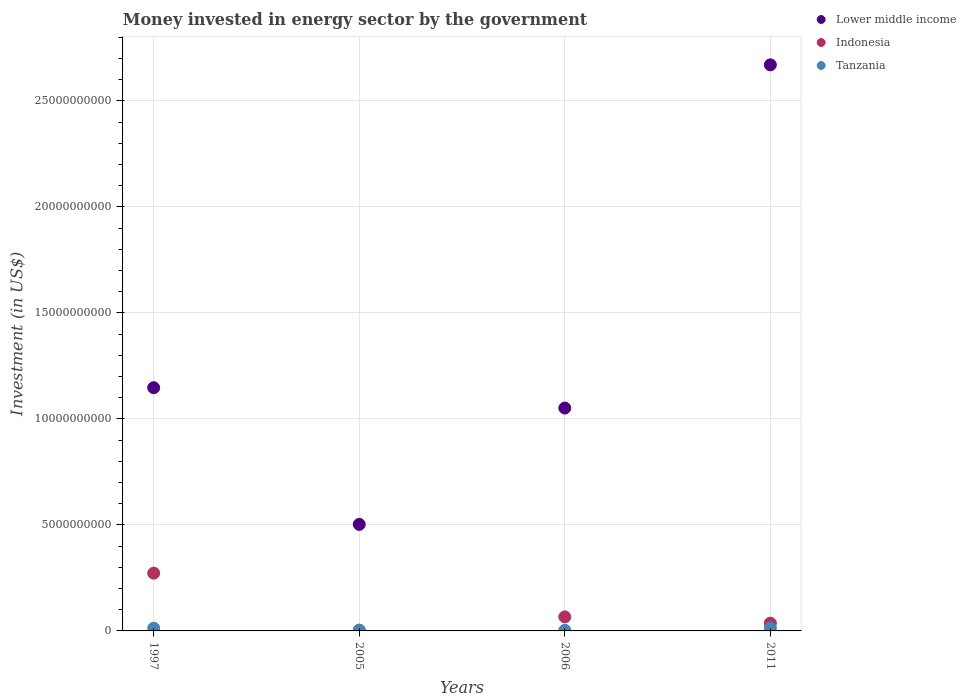How many different coloured dotlines are there?
Offer a very short reply. 3. Is the number of dotlines equal to the number of legend labels?
Ensure brevity in your answer.  Yes. What is the money spent in energy sector in Indonesia in 2006?
Ensure brevity in your answer.  6.62e+08. Across all years, what is the maximum money spent in energy sector in Tanzania?
Offer a terse response. 1.34e+08. Across all years, what is the minimum money spent in energy sector in Lower middle income?
Your answer should be very brief. 5.03e+09. What is the total money spent in energy sector in Tanzania in the graph?
Keep it short and to the point. 3.22e+08. What is the difference between the money spent in energy sector in Tanzania in 2006 and that in 2011?
Give a very brief answer. -1.06e+08. What is the difference between the money spent in energy sector in Lower middle income in 2006 and the money spent in energy sector in Indonesia in 1997?
Offer a terse response. 7.79e+09. What is the average money spent in energy sector in Tanzania per year?
Provide a short and direct response. 8.04e+07. In the year 2005, what is the difference between the money spent in energy sector in Lower middle income and money spent in energy sector in Tanzania?
Give a very brief answer. 4.99e+09. What is the ratio of the money spent in energy sector in Indonesia in 2006 to that in 2011?
Provide a short and direct response. 1.81. What is the difference between the highest and the second highest money spent in energy sector in Tanzania?
Ensure brevity in your answer.  7.10e+06. What is the difference between the highest and the lowest money spent in energy sector in Tanzania?
Your answer should be very brief. 1.06e+08. Does the money spent in energy sector in Indonesia monotonically increase over the years?
Make the answer very short. No. How many dotlines are there?
Your response must be concise. 3. How many years are there in the graph?
Ensure brevity in your answer.  4. Are the values on the major ticks of Y-axis written in scientific E-notation?
Give a very brief answer. No. Where does the legend appear in the graph?
Keep it short and to the point. Top right. What is the title of the graph?
Provide a succinct answer. Money invested in energy sector by the government. What is the label or title of the X-axis?
Your response must be concise. Years. What is the label or title of the Y-axis?
Offer a terse response. Investment (in US$). What is the Investment (in US$) in Lower middle income in 1997?
Offer a very short reply. 1.15e+1. What is the Investment (in US$) in Indonesia in 1997?
Provide a succinct answer. 2.72e+09. What is the Investment (in US$) in Tanzania in 1997?
Your response must be concise. 1.27e+08. What is the Investment (in US$) in Lower middle income in 2005?
Your answer should be compact. 5.03e+09. What is the Investment (in US$) of Indonesia in 2005?
Offer a terse response. 3.20e+07. What is the Investment (in US$) of Tanzania in 2005?
Make the answer very short. 3.20e+07. What is the Investment (in US$) in Lower middle income in 2006?
Make the answer very short. 1.05e+1. What is the Investment (in US$) in Indonesia in 2006?
Offer a very short reply. 6.62e+08. What is the Investment (in US$) of Tanzania in 2006?
Make the answer very short. 2.84e+07. What is the Investment (in US$) of Lower middle income in 2011?
Your response must be concise. 2.67e+1. What is the Investment (in US$) in Indonesia in 2011?
Your answer should be very brief. 3.66e+08. What is the Investment (in US$) of Tanzania in 2011?
Provide a short and direct response. 1.34e+08. Across all years, what is the maximum Investment (in US$) in Lower middle income?
Offer a very short reply. 2.67e+1. Across all years, what is the maximum Investment (in US$) in Indonesia?
Your answer should be compact. 2.72e+09. Across all years, what is the maximum Investment (in US$) of Tanzania?
Give a very brief answer. 1.34e+08. Across all years, what is the minimum Investment (in US$) in Lower middle income?
Ensure brevity in your answer.  5.03e+09. Across all years, what is the minimum Investment (in US$) of Indonesia?
Your answer should be very brief. 3.20e+07. Across all years, what is the minimum Investment (in US$) of Tanzania?
Ensure brevity in your answer.  2.84e+07. What is the total Investment (in US$) in Lower middle income in the graph?
Offer a terse response. 5.37e+1. What is the total Investment (in US$) of Indonesia in the graph?
Provide a succinct answer. 3.78e+09. What is the total Investment (in US$) of Tanzania in the graph?
Provide a short and direct response. 3.22e+08. What is the difference between the Investment (in US$) in Lower middle income in 1997 and that in 2005?
Make the answer very short. 6.45e+09. What is the difference between the Investment (in US$) in Indonesia in 1997 and that in 2005?
Your answer should be compact. 2.69e+09. What is the difference between the Investment (in US$) in Tanzania in 1997 and that in 2005?
Provide a short and direct response. 9.50e+07. What is the difference between the Investment (in US$) in Lower middle income in 1997 and that in 2006?
Offer a very short reply. 9.60e+08. What is the difference between the Investment (in US$) in Indonesia in 1997 and that in 2006?
Make the answer very short. 2.06e+09. What is the difference between the Investment (in US$) in Tanzania in 1997 and that in 2006?
Your response must be concise. 9.86e+07. What is the difference between the Investment (in US$) in Lower middle income in 1997 and that in 2011?
Give a very brief answer. -1.52e+1. What is the difference between the Investment (in US$) in Indonesia in 1997 and that in 2011?
Provide a succinct answer. 2.36e+09. What is the difference between the Investment (in US$) of Tanzania in 1997 and that in 2011?
Provide a short and direct response. -7.10e+06. What is the difference between the Investment (in US$) in Lower middle income in 2005 and that in 2006?
Your answer should be compact. -5.49e+09. What is the difference between the Investment (in US$) of Indonesia in 2005 and that in 2006?
Your answer should be compact. -6.30e+08. What is the difference between the Investment (in US$) in Tanzania in 2005 and that in 2006?
Offer a very short reply. 3.60e+06. What is the difference between the Investment (in US$) in Lower middle income in 2005 and that in 2011?
Your response must be concise. -2.17e+1. What is the difference between the Investment (in US$) of Indonesia in 2005 and that in 2011?
Keep it short and to the point. -3.34e+08. What is the difference between the Investment (in US$) in Tanzania in 2005 and that in 2011?
Your answer should be compact. -1.02e+08. What is the difference between the Investment (in US$) of Lower middle income in 2006 and that in 2011?
Provide a short and direct response. -1.62e+1. What is the difference between the Investment (in US$) in Indonesia in 2006 and that in 2011?
Offer a very short reply. 2.96e+08. What is the difference between the Investment (in US$) in Tanzania in 2006 and that in 2011?
Provide a succinct answer. -1.06e+08. What is the difference between the Investment (in US$) of Lower middle income in 1997 and the Investment (in US$) of Indonesia in 2005?
Provide a short and direct response. 1.14e+1. What is the difference between the Investment (in US$) in Lower middle income in 1997 and the Investment (in US$) in Tanzania in 2005?
Offer a terse response. 1.14e+1. What is the difference between the Investment (in US$) of Indonesia in 1997 and the Investment (in US$) of Tanzania in 2005?
Your answer should be compact. 2.69e+09. What is the difference between the Investment (in US$) of Lower middle income in 1997 and the Investment (in US$) of Indonesia in 2006?
Your response must be concise. 1.08e+1. What is the difference between the Investment (in US$) in Lower middle income in 1997 and the Investment (in US$) in Tanzania in 2006?
Your answer should be compact. 1.14e+1. What is the difference between the Investment (in US$) of Indonesia in 1997 and the Investment (in US$) of Tanzania in 2006?
Make the answer very short. 2.70e+09. What is the difference between the Investment (in US$) of Lower middle income in 1997 and the Investment (in US$) of Indonesia in 2011?
Your answer should be compact. 1.11e+1. What is the difference between the Investment (in US$) of Lower middle income in 1997 and the Investment (in US$) of Tanzania in 2011?
Ensure brevity in your answer.  1.13e+1. What is the difference between the Investment (in US$) in Indonesia in 1997 and the Investment (in US$) in Tanzania in 2011?
Keep it short and to the point. 2.59e+09. What is the difference between the Investment (in US$) of Lower middle income in 2005 and the Investment (in US$) of Indonesia in 2006?
Ensure brevity in your answer.  4.36e+09. What is the difference between the Investment (in US$) of Lower middle income in 2005 and the Investment (in US$) of Tanzania in 2006?
Offer a very short reply. 5.00e+09. What is the difference between the Investment (in US$) in Indonesia in 2005 and the Investment (in US$) in Tanzania in 2006?
Your answer should be compact. 3.60e+06. What is the difference between the Investment (in US$) of Lower middle income in 2005 and the Investment (in US$) of Indonesia in 2011?
Provide a succinct answer. 4.66e+09. What is the difference between the Investment (in US$) of Lower middle income in 2005 and the Investment (in US$) of Tanzania in 2011?
Your response must be concise. 4.89e+09. What is the difference between the Investment (in US$) in Indonesia in 2005 and the Investment (in US$) in Tanzania in 2011?
Provide a succinct answer. -1.02e+08. What is the difference between the Investment (in US$) in Lower middle income in 2006 and the Investment (in US$) in Indonesia in 2011?
Provide a succinct answer. 1.01e+1. What is the difference between the Investment (in US$) in Lower middle income in 2006 and the Investment (in US$) in Tanzania in 2011?
Make the answer very short. 1.04e+1. What is the difference between the Investment (in US$) of Indonesia in 2006 and the Investment (in US$) of Tanzania in 2011?
Offer a terse response. 5.28e+08. What is the average Investment (in US$) of Lower middle income per year?
Your answer should be very brief. 1.34e+1. What is the average Investment (in US$) in Indonesia per year?
Your answer should be compact. 9.46e+08. What is the average Investment (in US$) of Tanzania per year?
Ensure brevity in your answer.  8.04e+07. In the year 1997, what is the difference between the Investment (in US$) in Lower middle income and Investment (in US$) in Indonesia?
Your response must be concise. 8.75e+09. In the year 1997, what is the difference between the Investment (in US$) of Lower middle income and Investment (in US$) of Tanzania?
Make the answer very short. 1.13e+1. In the year 1997, what is the difference between the Investment (in US$) in Indonesia and Investment (in US$) in Tanzania?
Give a very brief answer. 2.60e+09. In the year 2005, what is the difference between the Investment (in US$) of Lower middle income and Investment (in US$) of Indonesia?
Offer a very short reply. 4.99e+09. In the year 2005, what is the difference between the Investment (in US$) in Lower middle income and Investment (in US$) in Tanzania?
Offer a terse response. 4.99e+09. In the year 2005, what is the difference between the Investment (in US$) in Indonesia and Investment (in US$) in Tanzania?
Offer a very short reply. 0. In the year 2006, what is the difference between the Investment (in US$) of Lower middle income and Investment (in US$) of Indonesia?
Offer a terse response. 9.85e+09. In the year 2006, what is the difference between the Investment (in US$) in Lower middle income and Investment (in US$) in Tanzania?
Offer a very short reply. 1.05e+1. In the year 2006, what is the difference between the Investment (in US$) of Indonesia and Investment (in US$) of Tanzania?
Your answer should be very brief. 6.34e+08. In the year 2011, what is the difference between the Investment (in US$) of Lower middle income and Investment (in US$) of Indonesia?
Your answer should be very brief. 2.63e+1. In the year 2011, what is the difference between the Investment (in US$) of Lower middle income and Investment (in US$) of Tanzania?
Ensure brevity in your answer.  2.66e+1. In the year 2011, what is the difference between the Investment (in US$) of Indonesia and Investment (in US$) of Tanzania?
Make the answer very short. 2.32e+08. What is the ratio of the Investment (in US$) of Lower middle income in 1997 to that in 2005?
Keep it short and to the point. 2.28. What is the ratio of the Investment (in US$) in Indonesia in 1997 to that in 2005?
Your answer should be very brief. 85.16. What is the ratio of the Investment (in US$) of Tanzania in 1997 to that in 2005?
Your answer should be compact. 3.97. What is the ratio of the Investment (in US$) in Lower middle income in 1997 to that in 2006?
Offer a very short reply. 1.09. What is the ratio of the Investment (in US$) of Indonesia in 1997 to that in 2006?
Your answer should be compact. 4.12. What is the ratio of the Investment (in US$) in Tanzania in 1997 to that in 2006?
Make the answer very short. 4.47. What is the ratio of the Investment (in US$) of Lower middle income in 1997 to that in 2011?
Keep it short and to the point. 0.43. What is the ratio of the Investment (in US$) in Indonesia in 1997 to that in 2011?
Ensure brevity in your answer.  7.45. What is the ratio of the Investment (in US$) of Tanzania in 1997 to that in 2011?
Your response must be concise. 0.95. What is the ratio of the Investment (in US$) of Lower middle income in 2005 to that in 2006?
Provide a short and direct response. 0.48. What is the ratio of the Investment (in US$) of Indonesia in 2005 to that in 2006?
Give a very brief answer. 0.05. What is the ratio of the Investment (in US$) of Tanzania in 2005 to that in 2006?
Offer a terse response. 1.13. What is the ratio of the Investment (in US$) of Lower middle income in 2005 to that in 2011?
Your answer should be very brief. 0.19. What is the ratio of the Investment (in US$) in Indonesia in 2005 to that in 2011?
Provide a short and direct response. 0.09. What is the ratio of the Investment (in US$) in Tanzania in 2005 to that in 2011?
Keep it short and to the point. 0.24. What is the ratio of the Investment (in US$) of Lower middle income in 2006 to that in 2011?
Ensure brevity in your answer.  0.39. What is the ratio of the Investment (in US$) of Indonesia in 2006 to that in 2011?
Provide a succinct answer. 1.81. What is the ratio of the Investment (in US$) of Tanzania in 2006 to that in 2011?
Offer a very short reply. 0.21. What is the difference between the highest and the second highest Investment (in US$) in Lower middle income?
Provide a short and direct response. 1.52e+1. What is the difference between the highest and the second highest Investment (in US$) in Indonesia?
Offer a terse response. 2.06e+09. What is the difference between the highest and the second highest Investment (in US$) of Tanzania?
Ensure brevity in your answer.  7.10e+06. What is the difference between the highest and the lowest Investment (in US$) in Lower middle income?
Your answer should be very brief. 2.17e+1. What is the difference between the highest and the lowest Investment (in US$) in Indonesia?
Make the answer very short. 2.69e+09. What is the difference between the highest and the lowest Investment (in US$) of Tanzania?
Ensure brevity in your answer.  1.06e+08. 